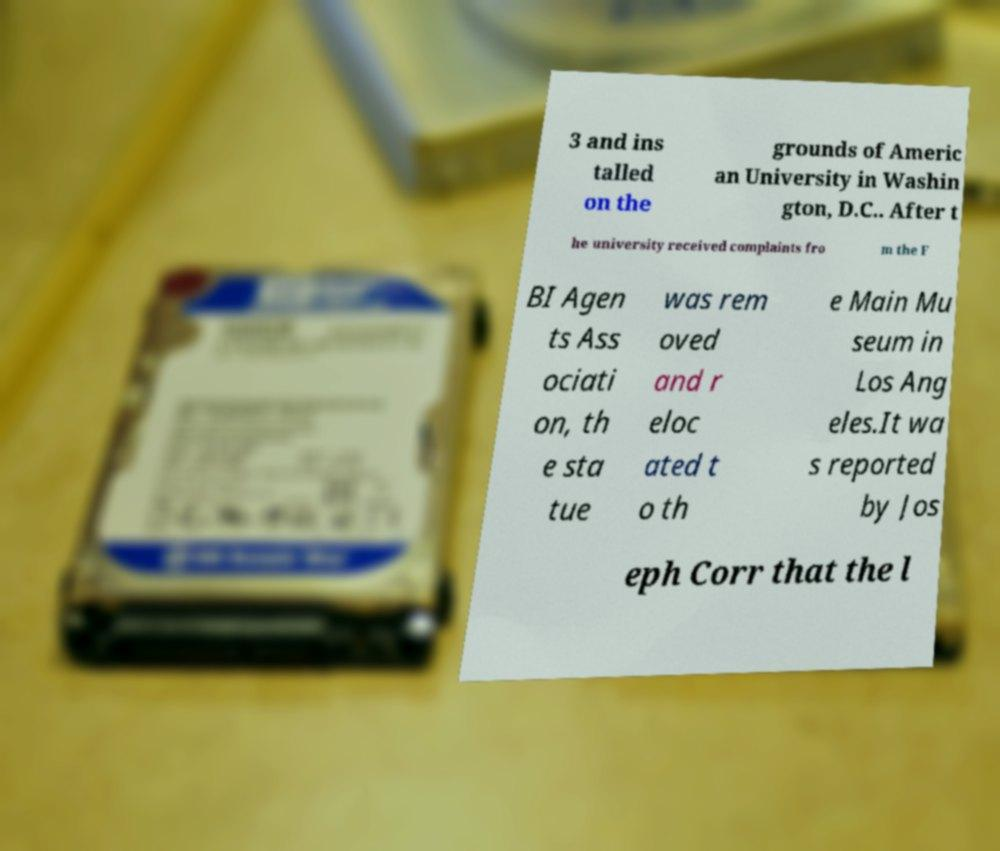Can you accurately transcribe the text from the provided image for me? 3 and ins talled on the grounds of Americ an University in Washin gton, D.C.. After t he university received complaints fro m the F BI Agen ts Ass ociati on, th e sta tue was rem oved and r eloc ated t o th e Main Mu seum in Los Ang eles.It wa s reported by Jos eph Corr that the l 